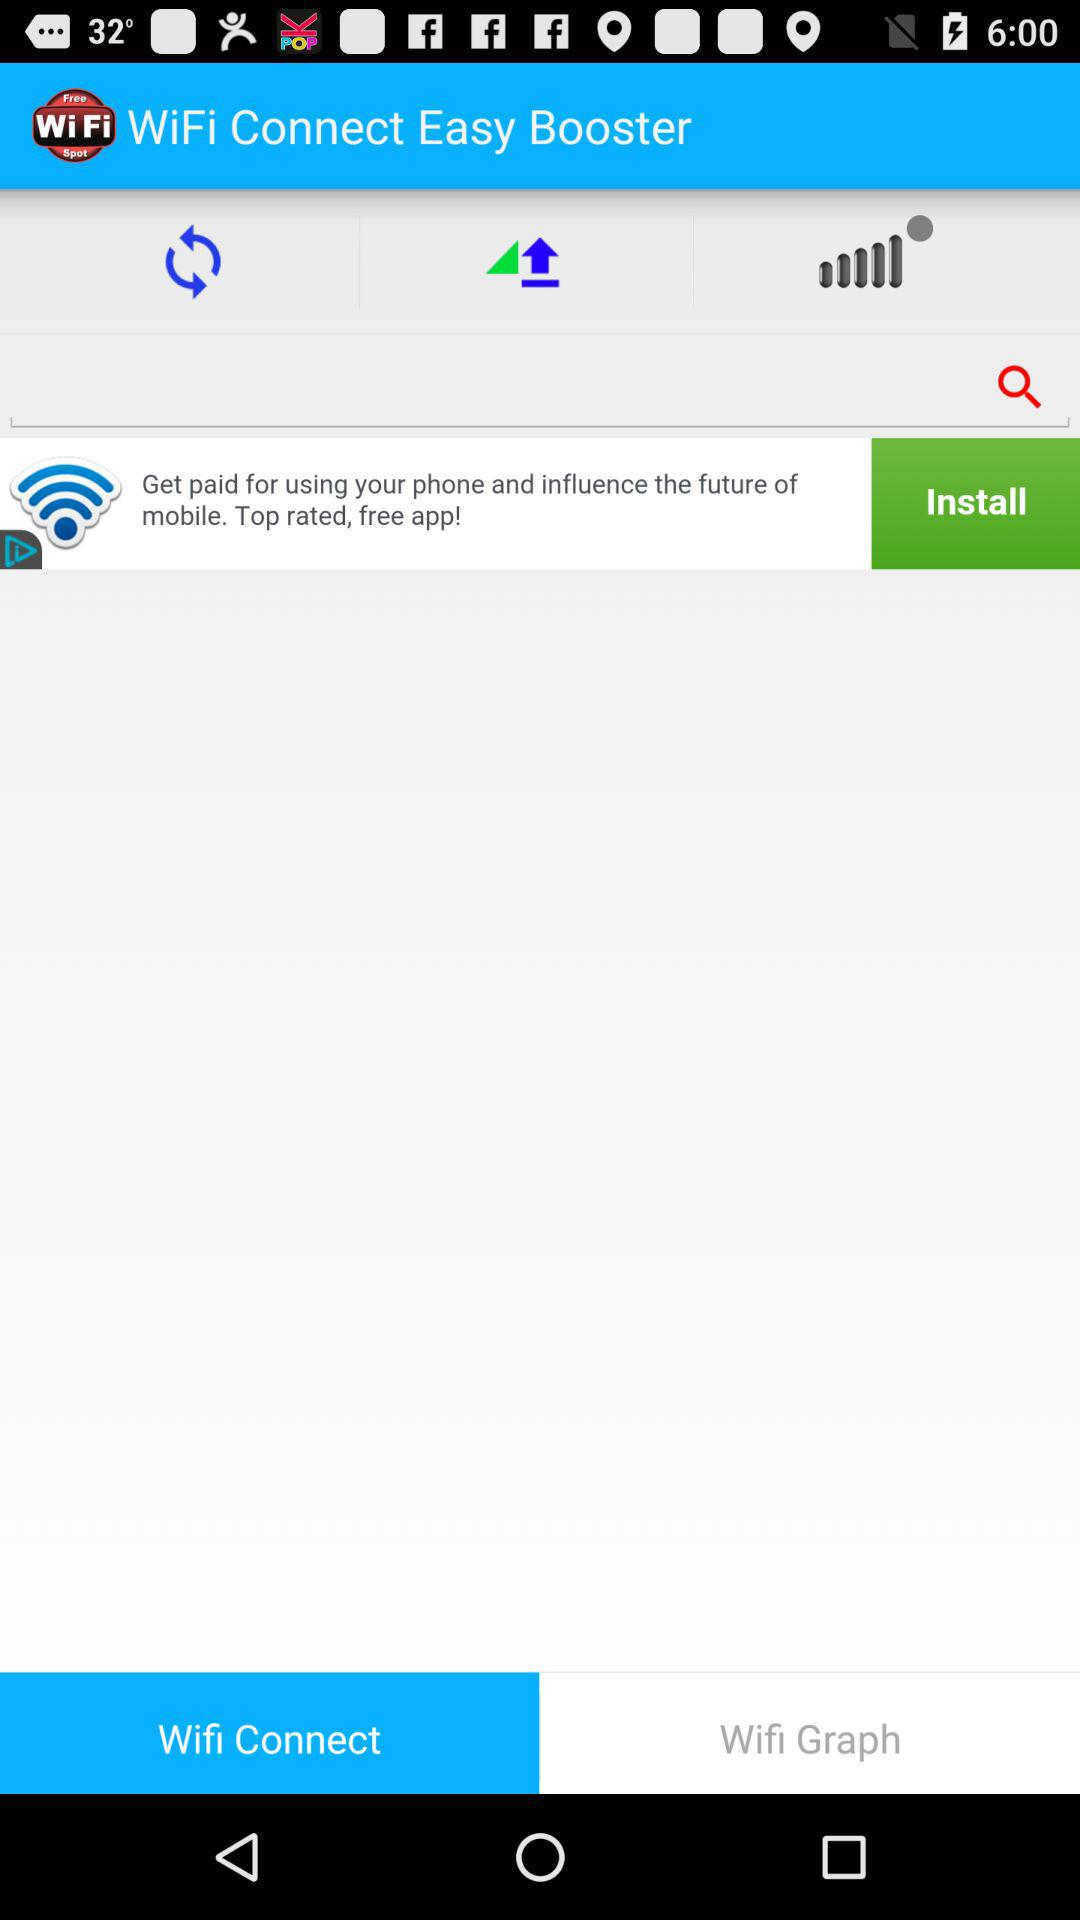Which tab is currently selected? The currently selected tab is "Wifi Connect". 